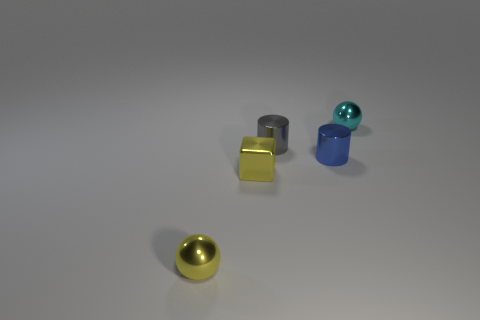Add 1 small red matte spheres. How many objects exist? 6 Subtract all blocks. How many objects are left? 4 Subtract 0 red cubes. How many objects are left? 5 Subtract all tiny metallic objects. Subtract all small red cylinders. How many objects are left? 0 Add 1 tiny yellow blocks. How many tiny yellow blocks are left? 2 Add 2 big blue matte things. How many big blue matte things exist? 2 